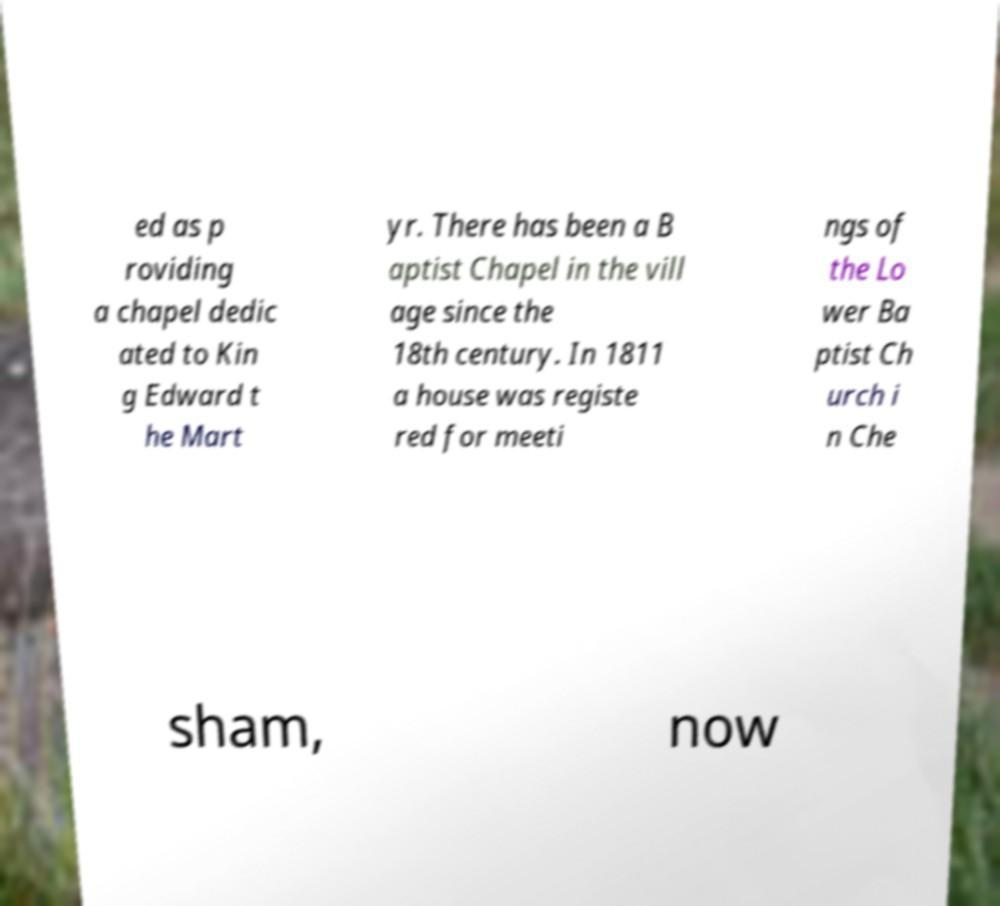Could you assist in decoding the text presented in this image and type it out clearly? ed as p roviding a chapel dedic ated to Kin g Edward t he Mart yr. There has been a B aptist Chapel in the vill age since the 18th century. In 1811 a house was registe red for meeti ngs of the Lo wer Ba ptist Ch urch i n Che sham, now 